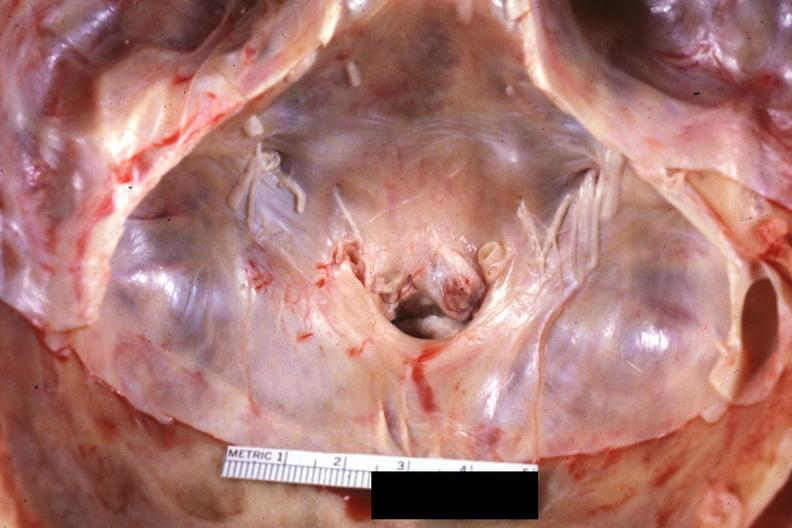s bone, calvarium present?
Answer the question using a single word or phrase. Yes 